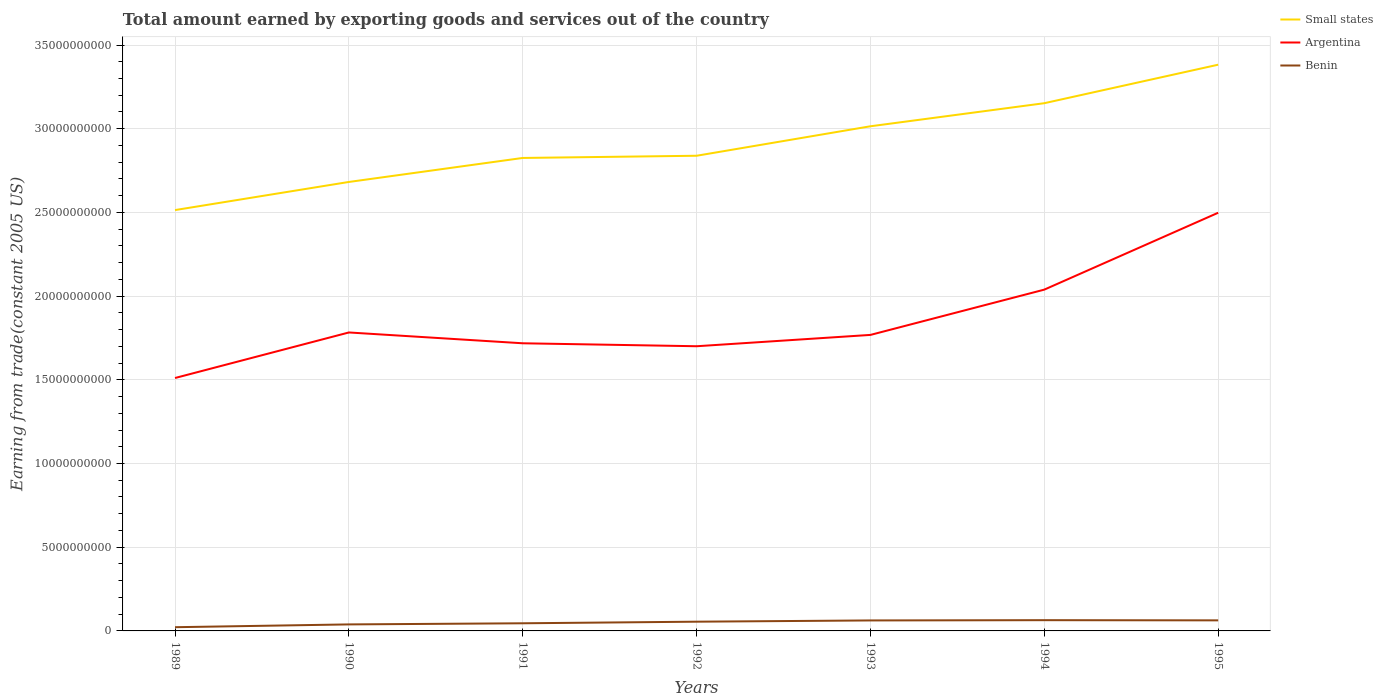How many different coloured lines are there?
Give a very brief answer. 3. Is the number of lines equal to the number of legend labels?
Ensure brevity in your answer.  Yes. Across all years, what is the maximum total amount earned by exporting goods and services in Argentina?
Make the answer very short. 1.51e+1. What is the total total amount earned by exporting goods and services in Small states in the graph?
Your response must be concise. -3.33e+09. What is the difference between the highest and the second highest total amount earned by exporting goods and services in Small states?
Ensure brevity in your answer.  8.68e+09. How many years are there in the graph?
Make the answer very short. 7. What is the difference between two consecutive major ticks on the Y-axis?
Provide a succinct answer. 5.00e+09. Are the values on the major ticks of Y-axis written in scientific E-notation?
Make the answer very short. No. Does the graph contain grids?
Make the answer very short. Yes. Where does the legend appear in the graph?
Give a very brief answer. Top right. How many legend labels are there?
Your answer should be very brief. 3. How are the legend labels stacked?
Make the answer very short. Vertical. What is the title of the graph?
Ensure brevity in your answer.  Total amount earned by exporting goods and services out of the country. What is the label or title of the X-axis?
Ensure brevity in your answer.  Years. What is the label or title of the Y-axis?
Provide a short and direct response. Earning from trade(constant 2005 US). What is the Earning from trade(constant 2005 US) of Small states in 1989?
Make the answer very short. 2.51e+1. What is the Earning from trade(constant 2005 US) in Argentina in 1989?
Ensure brevity in your answer.  1.51e+1. What is the Earning from trade(constant 2005 US) of Benin in 1989?
Ensure brevity in your answer.  2.22e+08. What is the Earning from trade(constant 2005 US) in Small states in 1990?
Make the answer very short. 2.68e+1. What is the Earning from trade(constant 2005 US) of Argentina in 1990?
Ensure brevity in your answer.  1.78e+1. What is the Earning from trade(constant 2005 US) in Benin in 1990?
Keep it short and to the point. 3.89e+08. What is the Earning from trade(constant 2005 US) of Small states in 1991?
Provide a succinct answer. 2.83e+1. What is the Earning from trade(constant 2005 US) in Argentina in 1991?
Provide a succinct answer. 1.72e+1. What is the Earning from trade(constant 2005 US) of Benin in 1991?
Your answer should be compact. 4.56e+08. What is the Earning from trade(constant 2005 US) in Small states in 1992?
Your answer should be very brief. 2.84e+1. What is the Earning from trade(constant 2005 US) of Argentina in 1992?
Offer a terse response. 1.70e+1. What is the Earning from trade(constant 2005 US) of Benin in 1992?
Provide a succinct answer. 5.52e+08. What is the Earning from trade(constant 2005 US) of Small states in 1993?
Your answer should be very brief. 3.01e+1. What is the Earning from trade(constant 2005 US) of Argentina in 1993?
Ensure brevity in your answer.  1.77e+1. What is the Earning from trade(constant 2005 US) in Benin in 1993?
Your answer should be very brief. 6.27e+08. What is the Earning from trade(constant 2005 US) in Small states in 1994?
Ensure brevity in your answer.  3.15e+1. What is the Earning from trade(constant 2005 US) of Argentina in 1994?
Your answer should be very brief. 2.04e+1. What is the Earning from trade(constant 2005 US) of Benin in 1994?
Offer a very short reply. 6.42e+08. What is the Earning from trade(constant 2005 US) in Small states in 1995?
Offer a very short reply. 3.38e+1. What is the Earning from trade(constant 2005 US) in Argentina in 1995?
Your response must be concise. 2.50e+1. What is the Earning from trade(constant 2005 US) of Benin in 1995?
Your answer should be very brief. 6.31e+08. Across all years, what is the maximum Earning from trade(constant 2005 US) in Small states?
Your response must be concise. 3.38e+1. Across all years, what is the maximum Earning from trade(constant 2005 US) in Argentina?
Your answer should be compact. 2.50e+1. Across all years, what is the maximum Earning from trade(constant 2005 US) of Benin?
Provide a short and direct response. 6.42e+08. Across all years, what is the minimum Earning from trade(constant 2005 US) in Small states?
Ensure brevity in your answer.  2.51e+1. Across all years, what is the minimum Earning from trade(constant 2005 US) of Argentina?
Your response must be concise. 1.51e+1. Across all years, what is the minimum Earning from trade(constant 2005 US) in Benin?
Provide a succinct answer. 2.22e+08. What is the total Earning from trade(constant 2005 US) in Small states in the graph?
Your response must be concise. 2.04e+11. What is the total Earning from trade(constant 2005 US) in Argentina in the graph?
Keep it short and to the point. 1.30e+11. What is the total Earning from trade(constant 2005 US) in Benin in the graph?
Your response must be concise. 3.52e+09. What is the difference between the Earning from trade(constant 2005 US) in Small states in 1989 and that in 1990?
Your response must be concise. -1.68e+09. What is the difference between the Earning from trade(constant 2005 US) in Argentina in 1989 and that in 1990?
Your answer should be compact. -2.72e+09. What is the difference between the Earning from trade(constant 2005 US) in Benin in 1989 and that in 1990?
Your answer should be compact. -1.67e+08. What is the difference between the Earning from trade(constant 2005 US) of Small states in 1989 and that in 1991?
Provide a short and direct response. -3.11e+09. What is the difference between the Earning from trade(constant 2005 US) in Argentina in 1989 and that in 1991?
Give a very brief answer. -2.07e+09. What is the difference between the Earning from trade(constant 2005 US) in Benin in 1989 and that in 1991?
Ensure brevity in your answer.  -2.34e+08. What is the difference between the Earning from trade(constant 2005 US) in Small states in 1989 and that in 1992?
Your answer should be very brief. -3.25e+09. What is the difference between the Earning from trade(constant 2005 US) of Argentina in 1989 and that in 1992?
Keep it short and to the point. -1.90e+09. What is the difference between the Earning from trade(constant 2005 US) in Benin in 1989 and that in 1992?
Your answer should be compact. -3.30e+08. What is the difference between the Earning from trade(constant 2005 US) in Small states in 1989 and that in 1993?
Provide a short and direct response. -5.01e+09. What is the difference between the Earning from trade(constant 2005 US) of Argentina in 1989 and that in 1993?
Ensure brevity in your answer.  -2.58e+09. What is the difference between the Earning from trade(constant 2005 US) in Benin in 1989 and that in 1993?
Your response must be concise. -4.04e+08. What is the difference between the Earning from trade(constant 2005 US) of Small states in 1989 and that in 1994?
Ensure brevity in your answer.  -6.38e+09. What is the difference between the Earning from trade(constant 2005 US) of Argentina in 1989 and that in 1994?
Your answer should be compact. -5.28e+09. What is the difference between the Earning from trade(constant 2005 US) in Benin in 1989 and that in 1994?
Offer a very short reply. -4.20e+08. What is the difference between the Earning from trade(constant 2005 US) in Small states in 1989 and that in 1995?
Provide a short and direct response. -8.68e+09. What is the difference between the Earning from trade(constant 2005 US) in Argentina in 1989 and that in 1995?
Make the answer very short. -9.87e+09. What is the difference between the Earning from trade(constant 2005 US) in Benin in 1989 and that in 1995?
Your answer should be compact. -4.08e+08. What is the difference between the Earning from trade(constant 2005 US) in Small states in 1990 and that in 1991?
Your answer should be compact. -1.43e+09. What is the difference between the Earning from trade(constant 2005 US) of Argentina in 1990 and that in 1991?
Your answer should be compact. 6.46e+08. What is the difference between the Earning from trade(constant 2005 US) of Benin in 1990 and that in 1991?
Your response must be concise. -6.73e+07. What is the difference between the Earning from trade(constant 2005 US) of Small states in 1990 and that in 1992?
Your answer should be very brief. -1.57e+09. What is the difference between the Earning from trade(constant 2005 US) of Argentina in 1990 and that in 1992?
Your answer should be very brief. 8.23e+08. What is the difference between the Earning from trade(constant 2005 US) of Benin in 1990 and that in 1992?
Give a very brief answer. -1.63e+08. What is the difference between the Earning from trade(constant 2005 US) of Small states in 1990 and that in 1993?
Give a very brief answer. -3.33e+09. What is the difference between the Earning from trade(constant 2005 US) in Argentina in 1990 and that in 1993?
Give a very brief answer. 1.46e+08. What is the difference between the Earning from trade(constant 2005 US) in Benin in 1990 and that in 1993?
Make the answer very short. -2.38e+08. What is the difference between the Earning from trade(constant 2005 US) in Small states in 1990 and that in 1994?
Keep it short and to the point. -4.70e+09. What is the difference between the Earning from trade(constant 2005 US) of Argentina in 1990 and that in 1994?
Keep it short and to the point. -2.56e+09. What is the difference between the Earning from trade(constant 2005 US) of Benin in 1990 and that in 1994?
Offer a terse response. -2.53e+08. What is the difference between the Earning from trade(constant 2005 US) of Small states in 1990 and that in 1995?
Offer a terse response. -7.00e+09. What is the difference between the Earning from trade(constant 2005 US) of Argentina in 1990 and that in 1995?
Make the answer very short. -7.15e+09. What is the difference between the Earning from trade(constant 2005 US) of Benin in 1990 and that in 1995?
Provide a succinct answer. -2.42e+08. What is the difference between the Earning from trade(constant 2005 US) of Small states in 1991 and that in 1992?
Offer a terse response. -1.31e+08. What is the difference between the Earning from trade(constant 2005 US) of Argentina in 1991 and that in 1992?
Your answer should be very brief. 1.77e+08. What is the difference between the Earning from trade(constant 2005 US) in Benin in 1991 and that in 1992?
Keep it short and to the point. -9.57e+07. What is the difference between the Earning from trade(constant 2005 US) of Small states in 1991 and that in 1993?
Ensure brevity in your answer.  -1.89e+09. What is the difference between the Earning from trade(constant 2005 US) in Argentina in 1991 and that in 1993?
Ensure brevity in your answer.  -5.00e+08. What is the difference between the Earning from trade(constant 2005 US) in Benin in 1991 and that in 1993?
Make the answer very short. -1.70e+08. What is the difference between the Earning from trade(constant 2005 US) in Small states in 1991 and that in 1994?
Keep it short and to the point. -3.27e+09. What is the difference between the Earning from trade(constant 2005 US) in Argentina in 1991 and that in 1994?
Your answer should be compact. -3.21e+09. What is the difference between the Earning from trade(constant 2005 US) in Benin in 1991 and that in 1994?
Your answer should be very brief. -1.86e+08. What is the difference between the Earning from trade(constant 2005 US) in Small states in 1991 and that in 1995?
Provide a short and direct response. -5.57e+09. What is the difference between the Earning from trade(constant 2005 US) in Argentina in 1991 and that in 1995?
Your response must be concise. -7.80e+09. What is the difference between the Earning from trade(constant 2005 US) in Benin in 1991 and that in 1995?
Give a very brief answer. -1.74e+08. What is the difference between the Earning from trade(constant 2005 US) in Small states in 1992 and that in 1993?
Keep it short and to the point. -1.76e+09. What is the difference between the Earning from trade(constant 2005 US) of Argentina in 1992 and that in 1993?
Make the answer very short. -6.77e+08. What is the difference between the Earning from trade(constant 2005 US) of Benin in 1992 and that in 1993?
Your answer should be very brief. -7.45e+07. What is the difference between the Earning from trade(constant 2005 US) of Small states in 1992 and that in 1994?
Offer a terse response. -3.14e+09. What is the difference between the Earning from trade(constant 2005 US) in Argentina in 1992 and that in 1994?
Provide a succinct answer. -3.38e+09. What is the difference between the Earning from trade(constant 2005 US) of Benin in 1992 and that in 1994?
Your answer should be compact. -8.99e+07. What is the difference between the Earning from trade(constant 2005 US) in Small states in 1992 and that in 1995?
Provide a short and direct response. -5.44e+09. What is the difference between the Earning from trade(constant 2005 US) in Argentina in 1992 and that in 1995?
Ensure brevity in your answer.  -7.98e+09. What is the difference between the Earning from trade(constant 2005 US) in Benin in 1992 and that in 1995?
Ensure brevity in your answer.  -7.86e+07. What is the difference between the Earning from trade(constant 2005 US) in Small states in 1993 and that in 1994?
Your answer should be very brief. -1.38e+09. What is the difference between the Earning from trade(constant 2005 US) of Argentina in 1993 and that in 1994?
Your answer should be very brief. -2.70e+09. What is the difference between the Earning from trade(constant 2005 US) in Benin in 1993 and that in 1994?
Your answer should be very brief. -1.53e+07. What is the difference between the Earning from trade(constant 2005 US) in Small states in 1993 and that in 1995?
Offer a terse response. -3.68e+09. What is the difference between the Earning from trade(constant 2005 US) in Argentina in 1993 and that in 1995?
Your response must be concise. -7.30e+09. What is the difference between the Earning from trade(constant 2005 US) of Benin in 1993 and that in 1995?
Offer a very short reply. -4.06e+06. What is the difference between the Earning from trade(constant 2005 US) of Small states in 1994 and that in 1995?
Give a very brief answer. -2.30e+09. What is the difference between the Earning from trade(constant 2005 US) in Argentina in 1994 and that in 1995?
Your response must be concise. -4.59e+09. What is the difference between the Earning from trade(constant 2005 US) in Benin in 1994 and that in 1995?
Offer a terse response. 1.13e+07. What is the difference between the Earning from trade(constant 2005 US) in Small states in 1989 and the Earning from trade(constant 2005 US) in Argentina in 1990?
Keep it short and to the point. 7.31e+09. What is the difference between the Earning from trade(constant 2005 US) of Small states in 1989 and the Earning from trade(constant 2005 US) of Benin in 1990?
Give a very brief answer. 2.48e+1. What is the difference between the Earning from trade(constant 2005 US) of Argentina in 1989 and the Earning from trade(constant 2005 US) of Benin in 1990?
Offer a terse response. 1.47e+1. What is the difference between the Earning from trade(constant 2005 US) in Small states in 1989 and the Earning from trade(constant 2005 US) in Argentina in 1991?
Ensure brevity in your answer.  7.96e+09. What is the difference between the Earning from trade(constant 2005 US) of Small states in 1989 and the Earning from trade(constant 2005 US) of Benin in 1991?
Keep it short and to the point. 2.47e+1. What is the difference between the Earning from trade(constant 2005 US) in Argentina in 1989 and the Earning from trade(constant 2005 US) in Benin in 1991?
Make the answer very short. 1.47e+1. What is the difference between the Earning from trade(constant 2005 US) in Small states in 1989 and the Earning from trade(constant 2005 US) in Argentina in 1992?
Your answer should be compact. 8.13e+09. What is the difference between the Earning from trade(constant 2005 US) in Small states in 1989 and the Earning from trade(constant 2005 US) in Benin in 1992?
Provide a short and direct response. 2.46e+1. What is the difference between the Earning from trade(constant 2005 US) in Argentina in 1989 and the Earning from trade(constant 2005 US) in Benin in 1992?
Give a very brief answer. 1.46e+1. What is the difference between the Earning from trade(constant 2005 US) in Small states in 1989 and the Earning from trade(constant 2005 US) in Argentina in 1993?
Ensure brevity in your answer.  7.46e+09. What is the difference between the Earning from trade(constant 2005 US) of Small states in 1989 and the Earning from trade(constant 2005 US) of Benin in 1993?
Give a very brief answer. 2.45e+1. What is the difference between the Earning from trade(constant 2005 US) of Argentina in 1989 and the Earning from trade(constant 2005 US) of Benin in 1993?
Your answer should be compact. 1.45e+1. What is the difference between the Earning from trade(constant 2005 US) in Small states in 1989 and the Earning from trade(constant 2005 US) in Argentina in 1994?
Offer a very short reply. 4.75e+09. What is the difference between the Earning from trade(constant 2005 US) in Small states in 1989 and the Earning from trade(constant 2005 US) in Benin in 1994?
Offer a terse response. 2.45e+1. What is the difference between the Earning from trade(constant 2005 US) of Argentina in 1989 and the Earning from trade(constant 2005 US) of Benin in 1994?
Provide a short and direct response. 1.45e+1. What is the difference between the Earning from trade(constant 2005 US) of Small states in 1989 and the Earning from trade(constant 2005 US) of Argentina in 1995?
Offer a very short reply. 1.59e+08. What is the difference between the Earning from trade(constant 2005 US) in Small states in 1989 and the Earning from trade(constant 2005 US) in Benin in 1995?
Provide a succinct answer. 2.45e+1. What is the difference between the Earning from trade(constant 2005 US) in Argentina in 1989 and the Earning from trade(constant 2005 US) in Benin in 1995?
Give a very brief answer. 1.45e+1. What is the difference between the Earning from trade(constant 2005 US) in Small states in 1990 and the Earning from trade(constant 2005 US) in Argentina in 1991?
Offer a terse response. 9.64e+09. What is the difference between the Earning from trade(constant 2005 US) of Small states in 1990 and the Earning from trade(constant 2005 US) of Benin in 1991?
Your answer should be very brief. 2.64e+1. What is the difference between the Earning from trade(constant 2005 US) of Argentina in 1990 and the Earning from trade(constant 2005 US) of Benin in 1991?
Provide a succinct answer. 1.74e+1. What is the difference between the Earning from trade(constant 2005 US) of Small states in 1990 and the Earning from trade(constant 2005 US) of Argentina in 1992?
Keep it short and to the point. 9.81e+09. What is the difference between the Earning from trade(constant 2005 US) of Small states in 1990 and the Earning from trade(constant 2005 US) of Benin in 1992?
Your answer should be very brief. 2.63e+1. What is the difference between the Earning from trade(constant 2005 US) of Argentina in 1990 and the Earning from trade(constant 2005 US) of Benin in 1992?
Keep it short and to the point. 1.73e+1. What is the difference between the Earning from trade(constant 2005 US) in Small states in 1990 and the Earning from trade(constant 2005 US) in Argentina in 1993?
Keep it short and to the point. 9.14e+09. What is the difference between the Earning from trade(constant 2005 US) of Small states in 1990 and the Earning from trade(constant 2005 US) of Benin in 1993?
Give a very brief answer. 2.62e+1. What is the difference between the Earning from trade(constant 2005 US) of Argentina in 1990 and the Earning from trade(constant 2005 US) of Benin in 1993?
Your answer should be very brief. 1.72e+1. What is the difference between the Earning from trade(constant 2005 US) in Small states in 1990 and the Earning from trade(constant 2005 US) in Argentina in 1994?
Provide a short and direct response. 6.43e+09. What is the difference between the Earning from trade(constant 2005 US) in Small states in 1990 and the Earning from trade(constant 2005 US) in Benin in 1994?
Ensure brevity in your answer.  2.62e+1. What is the difference between the Earning from trade(constant 2005 US) of Argentina in 1990 and the Earning from trade(constant 2005 US) of Benin in 1994?
Offer a terse response. 1.72e+1. What is the difference between the Earning from trade(constant 2005 US) in Small states in 1990 and the Earning from trade(constant 2005 US) in Argentina in 1995?
Your answer should be compact. 1.84e+09. What is the difference between the Earning from trade(constant 2005 US) in Small states in 1990 and the Earning from trade(constant 2005 US) in Benin in 1995?
Your answer should be very brief. 2.62e+1. What is the difference between the Earning from trade(constant 2005 US) of Argentina in 1990 and the Earning from trade(constant 2005 US) of Benin in 1995?
Give a very brief answer. 1.72e+1. What is the difference between the Earning from trade(constant 2005 US) of Small states in 1991 and the Earning from trade(constant 2005 US) of Argentina in 1992?
Provide a short and direct response. 1.12e+1. What is the difference between the Earning from trade(constant 2005 US) of Small states in 1991 and the Earning from trade(constant 2005 US) of Benin in 1992?
Your answer should be compact. 2.77e+1. What is the difference between the Earning from trade(constant 2005 US) in Argentina in 1991 and the Earning from trade(constant 2005 US) in Benin in 1992?
Offer a very short reply. 1.66e+1. What is the difference between the Earning from trade(constant 2005 US) of Small states in 1991 and the Earning from trade(constant 2005 US) of Argentina in 1993?
Your response must be concise. 1.06e+1. What is the difference between the Earning from trade(constant 2005 US) of Small states in 1991 and the Earning from trade(constant 2005 US) of Benin in 1993?
Keep it short and to the point. 2.76e+1. What is the difference between the Earning from trade(constant 2005 US) of Argentina in 1991 and the Earning from trade(constant 2005 US) of Benin in 1993?
Offer a very short reply. 1.66e+1. What is the difference between the Earning from trade(constant 2005 US) in Small states in 1991 and the Earning from trade(constant 2005 US) in Argentina in 1994?
Offer a terse response. 7.87e+09. What is the difference between the Earning from trade(constant 2005 US) of Small states in 1991 and the Earning from trade(constant 2005 US) of Benin in 1994?
Offer a very short reply. 2.76e+1. What is the difference between the Earning from trade(constant 2005 US) in Argentina in 1991 and the Earning from trade(constant 2005 US) in Benin in 1994?
Keep it short and to the point. 1.65e+1. What is the difference between the Earning from trade(constant 2005 US) of Small states in 1991 and the Earning from trade(constant 2005 US) of Argentina in 1995?
Your answer should be very brief. 3.27e+09. What is the difference between the Earning from trade(constant 2005 US) in Small states in 1991 and the Earning from trade(constant 2005 US) in Benin in 1995?
Give a very brief answer. 2.76e+1. What is the difference between the Earning from trade(constant 2005 US) in Argentina in 1991 and the Earning from trade(constant 2005 US) in Benin in 1995?
Keep it short and to the point. 1.66e+1. What is the difference between the Earning from trade(constant 2005 US) in Small states in 1992 and the Earning from trade(constant 2005 US) in Argentina in 1993?
Provide a succinct answer. 1.07e+1. What is the difference between the Earning from trade(constant 2005 US) in Small states in 1992 and the Earning from trade(constant 2005 US) in Benin in 1993?
Provide a short and direct response. 2.78e+1. What is the difference between the Earning from trade(constant 2005 US) of Argentina in 1992 and the Earning from trade(constant 2005 US) of Benin in 1993?
Provide a succinct answer. 1.64e+1. What is the difference between the Earning from trade(constant 2005 US) of Small states in 1992 and the Earning from trade(constant 2005 US) of Argentina in 1994?
Your answer should be very brief. 8.00e+09. What is the difference between the Earning from trade(constant 2005 US) of Small states in 1992 and the Earning from trade(constant 2005 US) of Benin in 1994?
Offer a very short reply. 2.77e+1. What is the difference between the Earning from trade(constant 2005 US) of Argentina in 1992 and the Earning from trade(constant 2005 US) of Benin in 1994?
Ensure brevity in your answer.  1.64e+1. What is the difference between the Earning from trade(constant 2005 US) in Small states in 1992 and the Earning from trade(constant 2005 US) in Argentina in 1995?
Give a very brief answer. 3.40e+09. What is the difference between the Earning from trade(constant 2005 US) in Small states in 1992 and the Earning from trade(constant 2005 US) in Benin in 1995?
Provide a succinct answer. 2.78e+1. What is the difference between the Earning from trade(constant 2005 US) in Argentina in 1992 and the Earning from trade(constant 2005 US) in Benin in 1995?
Offer a terse response. 1.64e+1. What is the difference between the Earning from trade(constant 2005 US) in Small states in 1993 and the Earning from trade(constant 2005 US) in Argentina in 1994?
Offer a very short reply. 9.76e+09. What is the difference between the Earning from trade(constant 2005 US) in Small states in 1993 and the Earning from trade(constant 2005 US) in Benin in 1994?
Offer a terse response. 2.95e+1. What is the difference between the Earning from trade(constant 2005 US) of Argentina in 1993 and the Earning from trade(constant 2005 US) of Benin in 1994?
Give a very brief answer. 1.70e+1. What is the difference between the Earning from trade(constant 2005 US) of Small states in 1993 and the Earning from trade(constant 2005 US) of Argentina in 1995?
Make the answer very short. 5.17e+09. What is the difference between the Earning from trade(constant 2005 US) of Small states in 1993 and the Earning from trade(constant 2005 US) of Benin in 1995?
Provide a short and direct response. 2.95e+1. What is the difference between the Earning from trade(constant 2005 US) in Argentina in 1993 and the Earning from trade(constant 2005 US) in Benin in 1995?
Your answer should be compact. 1.71e+1. What is the difference between the Earning from trade(constant 2005 US) of Small states in 1994 and the Earning from trade(constant 2005 US) of Argentina in 1995?
Offer a very short reply. 6.54e+09. What is the difference between the Earning from trade(constant 2005 US) of Small states in 1994 and the Earning from trade(constant 2005 US) of Benin in 1995?
Your answer should be compact. 3.09e+1. What is the difference between the Earning from trade(constant 2005 US) in Argentina in 1994 and the Earning from trade(constant 2005 US) in Benin in 1995?
Make the answer very short. 1.98e+1. What is the average Earning from trade(constant 2005 US) of Small states per year?
Offer a very short reply. 2.92e+1. What is the average Earning from trade(constant 2005 US) in Argentina per year?
Keep it short and to the point. 1.86e+1. What is the average Earning from trade(constant 2005 US) in Benin per year?
Your answer should be very brief. 5.03e+08. In the year 1989, what is the difference between the Earning from trade(constant 2005 US) of Small states and Earning from trade(constant 2005 US) of Argentina?
Keep it short and to the point. 1.00e+1. In the year 1989, what is the difference between the Earning from trade(constant 2005 US) of Small states and Earning from trade(constant 2005 US) of Benin?
Offer a terse response. 2.49e+1. In the year 1989, what is the difference between the Earning from trade(constant 2005 US) in Argentina and Earning from trade(constant 2005 US) in Benin?
Make the answer very short. 1.49e+1. In the year 1990, what is the difference between the Earning from trade(constant 2005 US) of Small states and Earning from trade(constant 2005 US) of Argentina?
Offer a terse response. 8.99e+09. In the year 1990, what is the difference between the Earning from trade(constant 2005 US) of Small states and Earning from trade(constant 2005 US) of Benin?
Provide a short and direct response. 2.64e+1. In the year 1990, what is the difference between the Earning from trade(constant 2005 US) of Argentina and Earning from trade(constant 2005 US) of Benin?
Your response must be concise. 1.74e+1. In the year 1991, what is the difference between the Earning from trade(constant 2005 US) in Small states and Earning from trade(constant 2005 US) in Argentina?
Your response must be concise. 1.11e+1. In the year 1991, what is the difference between the Earning from trade(constant 2005 US) in Small states and Earning from trade(constant 2005 US) in Benin?
Provide a succinct answer. 2.78e+1. In the year 1991, what is the difference between the Earning from trade(constant 2005 US) of Argentina and Earning from trade(constant 2005 US) of Benin?
Your answer should be compact. 1.67e+1. In the year 1992, what is the difference between the Earning from trade(constant 2005 US) in Small states and Earning from trade(constant 2005 US) in Argentina?
Give a very brief answer. 1.14e+1. In the year 1992, what is the difference between the Earning from trade(constant 2005 US) of Small states and Earning from trade(constant 2005 US) of Benin?
Give a very brief answer. 2.78e+1. In the year 1992, what is the difference between the Earning from trade(constant 2005 US) of Argentina and Earning from trade(constant 2005 US) of Benin?
Your answer should be very brief. 1.65e+1. In the year 1993, what is the difference between the Earning from trade(constant 2005 US) in Small states and Earning from trade(constant 2005 US) in Argentina?
Your answer should be compact. 1.25e+1. In the year 1993, what is the difference between the Earning from trade(constant 2005 US) of Small states and Earning from trade(constant 2005 US) of Benin?
Your answer should be very brief. 2.95e+1. In the year 1993, what is the difference between the Earning from trade(constant 2005 US) in Argentina and Earning from trade(constant 2005 US) in Benin?
Your answer should be compact. 1.71e+1. In the year 1994, what is the difference between the Earning from trade(constant 2005 US) in Small states and Earning from trade(constant 2005 US) in Argentina?
Your answer should be very brief. 1.11e+1. In the year 1994, what is the difference between the Earning from trade(constant 2005 US) in Small states and Earning from trade(constant 2005 US) in Benin?
Your response must be concise. 3.09e+1. In the year 1994, what is the difference between the Earning from trade(constant 2005 US) in Argentina and Earning from trade(constant 2005 US) in Benin?
Provide a short and direct response. 1.97e+1. In the year 1995, what is the difference between the Earning from trade(constant 2005 US) of Small states and Earning from trade(constant 2005 US) of Argentina?
Ensure brevity in your answer.  8.84e+09. In the year 1995, what is the difference between the Earning from trade(constant 2005 US) of Small states and Earning from trade(constant 2005 US) of Benin?
Make the answer very short. 3.32e+1. In the year 1995, what is the difference between the Earning from trade(constant 2005 US) of Argentina and Earning from trade(constant 2005 US) of Benin?
Offer a very short reply. 2.44e+1. What is the ratio of the Earning from trade(constant 2005 US) in Small states in 1989 to that in 1990?
Provide a succinct answer. 0.94. What is the ratio of the Earning from trade(constant 2005 US) in Argentina in 1989 to that in 1990?
Offer a terse response. 0.85. What is the ratio of the Earning from trade(constant 2005 US) of Benin in 1989 to that in 1990?
Make the answer very short. 0.57. What is the ratio of the Earning from trade(constant 2005 US) in Small states in 1989 to that in 1991?
Your answer should be compact. 0.89. What is the ratio of the Earning from trade(constant 2005 US) of Argentina in 1989 to that in 1991?
Your answer should be very brief. 0.88. What is the ratio of the Earning from trade(constant 2005 US) of Benin in 1989 to that in 1991?
Offer a very short reply. 0.49. What is the ratio of the Earning from trade(constant 2005 US) in Small states in 1989 to that in 1992?
Offer a terse response. 0.89. What is the ratio of the Earning from trade(constant 2005 US) of Argentina in 1989 to that in 1992?
Your answer should be compact. 0.89. What is the ratio of the Earning from trade(constant 2005 US) in Benin in 1989 to that in 1992?
Keep it short and to the point. 0.4. What is the ratio of the Earning from trade(constant 2005 US) of Small states in 1989 to that in 1993?
Provide a succinct answer. 0.83. What is the ratio of the Earning from trade(constant 2005 US) of Argentina in 1989 to that in 1993?
Offer a terse response. 0.85. What is the ratio of the Earning from trade(constant 2005 US) in Benin in 1989 to that in 1993?
Offer a very short reply. 0.35. What is the ratio of the Earning from trade(constant 2005 US) of Small states in 1989 to that in 1994?
Ensure brevity in your answer.  0.8. What is the ratio of the Earning from trade(constant 2005 US) of Argentina in 1989 to that in 1994?
Your response must be concise. 0.74. What is the ratio of the Earning from trade(constant 2005 US) of Benin in 1989 to that in 1994?
Offer a terse response. 0.35. What is the ratio of the Earning from trade(constant 2005 US) in Small states in 1989 to that in 1995?
Ensure brevity in your answer.  0.74. What is the ratio of the Earning from trade(constant 2005 US) of Argentina in 1989 to that in 1995?
Provide a succinct answer. 0.6. What is the ratio of the Earning from trade(constant 2005 US) in Benin in 1989 to that in 1995?
Your answer should be compact. 0.35. What is the ratio of the Earning from trade(constant 2005 US) of Small states in 1990 to that in 1991?
Provide a short and direct response. 0.95. What is the ratio of the Earning from trade(constant 2005 US) of Argentina in 1990 to that in 1991?
Offer a very short reply. 1.04. What is the ratio of the Earning from trade(constant 2005 US) of Benin in 1990 to that in 1991?
Keep it short and to the point. 0.85. What is the ratio of the Earning from trade(constant 2005 US) of Small states in 1990 to that in 1992?
Provide a short and direct response. 0.94. What is the ratio of the Earning from trade(constant 2005 US) in Argentina in 1990 to that in 1992?
Your response must be concise. 1.05. What is the ratio of the Earning from trade(constant 2005 US) in Benin in 1990 to that in 1992?
Provide a succinct answer. 0.7. What is the ratio of the Earning from trade(constant 2005 US) in Small states in 1990 to that in 1993?
Your answer should be very brief. 0.89. What is the ratio of the Earning from trade(constant 2005 US) of Argentina in 1990 to that in 1993?
Give a very brief answer. 1.01. What is the ratio of the Earning from trade(constant 2005 US) in Benin in 1990 to that in 1993?
Keep it short and to the point. 0.62. What is the ratio of the Earning from trade(constant 2005 US) of Small states in 1990 to that in 1994?
Offer a terse response. 0.85. What is the ratio of the Earning from trade(constant 2005 US) of Argentina in 1990 to that in 1994?
Provide a short and direct response. 0.87. What is the ratio of the Earning from trade(constant 2005 US) of Benin in 1990 to that in 1994?
Ensure brevity in your answer.  0.61. What is the ratio of the Earning from trade(constant 2005 US) of Small states in 1990 to that in 1995?
Offer a terse response. 0.79. What is the ratio of the Earning from trade(constant 2005 US) of Argentina in 1990 to that in 1995?
Keep it short and to the point. 0.71. What is the ratio of the Earning from trade(constant 2005 US) of Benin in 1990 to that in 1995?
Your answer should be compact. 0.62. What is the ratio of the Earning from trade(constant 2005 US) in Argentina in 1991 to that in 1992?
Give a very brief answer. 1.01. What is the ratio of the Earning from trade(constant 2005 US) of Benin in 1991 to that in 1992?
Give a very brief answer. 0.83. What is the ratio of the Earning from trade(constant 2005 US) of Small states in 1991 to that in 1993?
Provide a short and direct response. 0.94. What is the ratio of the Earning from trade(constant 2005 US) of Argentina in 1991 to that in 1993?
Your response must be concise. 0.97. What is the ratio of the Earning from trade(constant 2005 US) in Benin in 1991 to that in 1993?
Keep it short and to the point. 0.73. What is the ratio of the Earning from trade(constant 2005 US) of Small states in 1991 to that in 1994?
Offer a terse response. 0.9. What is the ratio of the Earning from trade(constant 2005 US) of Argentina in 1991 to that in 1994?
Your answer should be very brief. 0.84. What is the ratio of the Earning from trade(constant 2005 US) in Benin in 1991 to that in 1994?
Your answer should be very brief. 0.71. What is the ratio of the Earning from trade(constant 2005 US) in Small states in 1991 to that in 1995?
Provide a succinct answer. 0.84. What is the ratio of the Earning from trade(constant 2005 US) in Argentina in 1991 to that in 1995?
Your answer should be compact. 0.69. What is the ratio of the Earning from trade(constant 2005 US) in Benin in 1991 to that in 1995?
Offer a terse response. 0.72. What is the ratio of the Earning from trade(constant 2005 US) in Small states in 1992 to that in 1993?
Provide a succinct answer. 0.94. What is the ratio of the Earning from trade(constant 2005 US) in Argentina in 1992 to that in 1993?
Make the answer very short. 0.96. What is the ratio of the Earning from trade(constant 2005 US) of Benin in 1992 to that in 1993?
Give a very brief answer. 0.88. What is the ratio of the Earning from trade(constant 2005 US) of Small states in 1992 to that in 1994?
Keep it short and to the point. 0.9. What is the ratio of the Earning from trade(constant 2005 US) in Argentina in 1992 to that in 1994?
Your response must be concise. 0.83. What is the ratio of the Earning from trade(constant 2005 US) in Benin in 1992 to that in 1994?
Keep it short and to the point. 0.86. What is the ratio of the Earning from trade(constant 2005 US) in Small states in 1992 to that in 1995?
Make the answer very short. 0.84. What is the ratio of the Earning from trade(constant 2005 US) of Argentina in 1992 to that in 1995?
Make the answer very short. 0.68. What is the ratio of the Earning from trade(constant 2005 US) of Benin in 1992 to that in 1995?
Your answer should be very brief. 0.88. What is the ratio of the Earning from trade(constant 2005 US) of Small states in 1993 to that in 1994?
Provide a succinct answer. 0.96. What is the ratio of the Earning from trade(constant 2005 US) of Argentina in 1993 to that in 1994?
Give a very brief answer. 0.87. What is the ratio of the Earning from trade(constant 2005 US) of Benin in 1993 to that in 1994?
Ensure brevity in your answer.  0.98. What is the ratio of the Earning from trade(constant 2005 US) of Small states in 1993 to that in 1995?
Provide a succinct answer. 0.89. What is the ratio of the Earning from trade(constant 2005 US) in Argentina in 1993 to that in 1995?
Your answer should be very brief. 0.71. What is the ratio of the Earning from trade(constant 2005 US) in Small states in 1994 to that in 1995?
Provide a short and direct response. 0.93. What is the ratio of the Earning from trade(constant 2005 US) in Argentina in 1994 to that in 1995?
Make the answer very short. 0.82. What is the ratio of the Earning from trade(constant 2005 US) of Benin in 1994 to that in 1995?
Your answer should be very brief. 1.02. What is the difference between the highest and the second highest Earning from trade(constant 2005 US) of Small states?
Offer a very short reply. 2.30e+09. What is the difference between the highest and the second highest Earning from trade(constant 2005 US) of Argentina?
Your response must be concise. 4.59e+09. What is the difference between the highest and the second highest Earning from trade(constant 2005 US) of Benin?
Offer a very short reply. 1.13e+07. What is the difference between the highest and the lowest Earning from trade(constant 2005 US) in Small states?
Your response must be concise. 8.68e+09. What is the difference between the highest and the lowest Earning from trade(constant 2005 US) of Argentina?
Provide a succinct answer. 9.87e+09. What is the difference between the highest and the lowest Earning from trade(constant 2005 US) in Benin?
Give a very brief answer. 4.20e+08. 